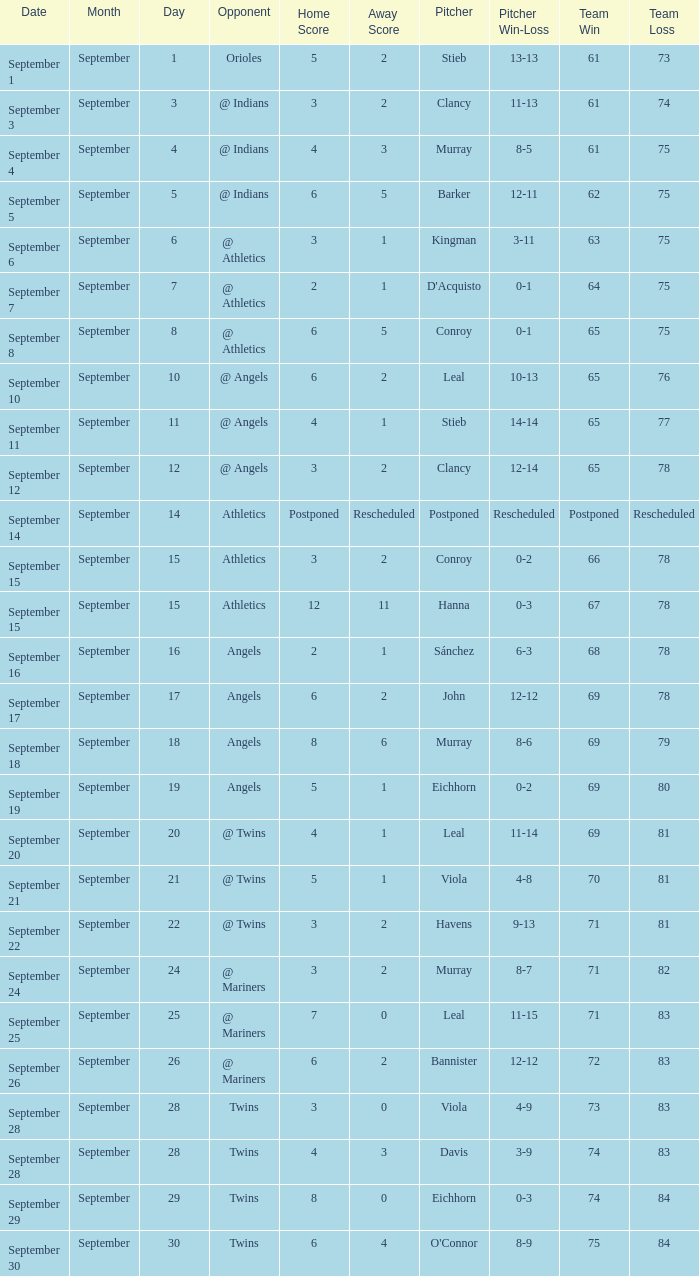Name the score which has record of 73-83 3 - 0. 